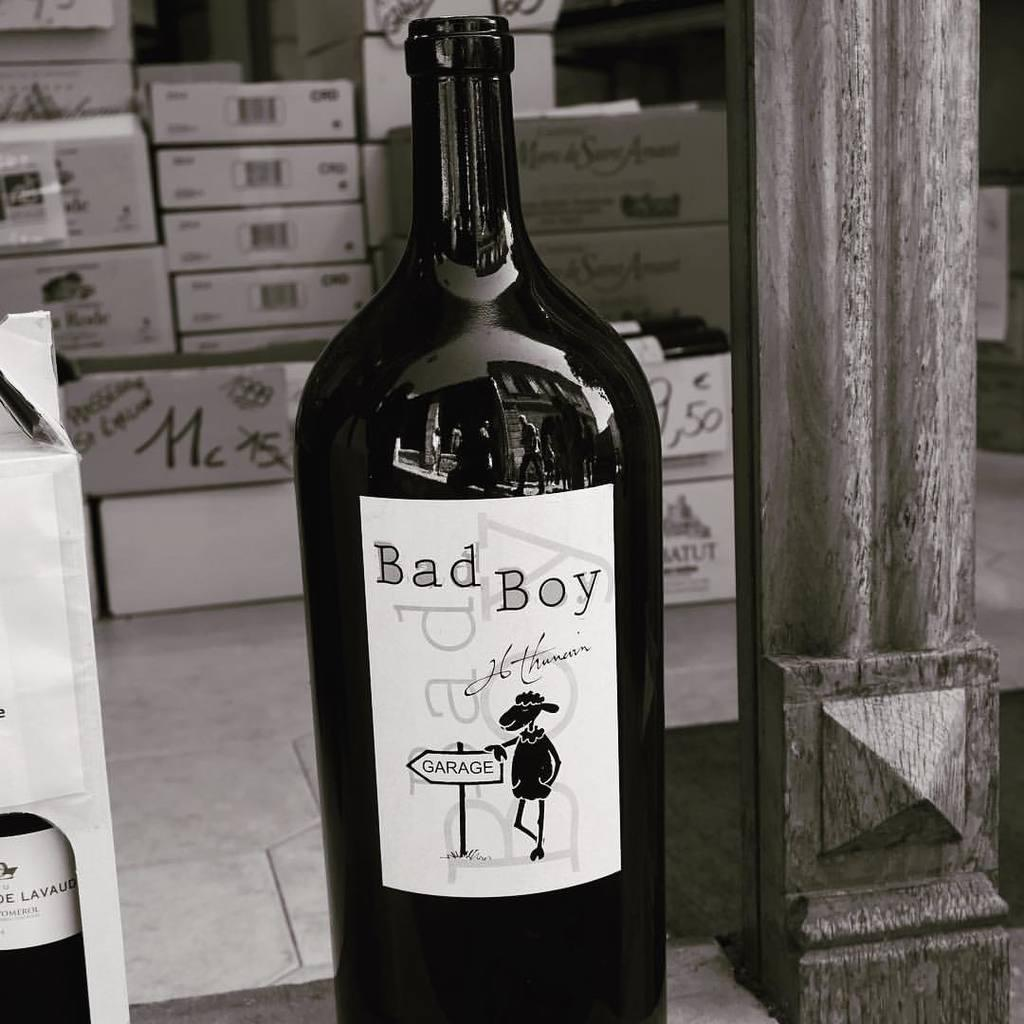Provide a one-sentence caption for the provided image. A bottle of Bad Boy sits next to a box of some other type of beverage. 